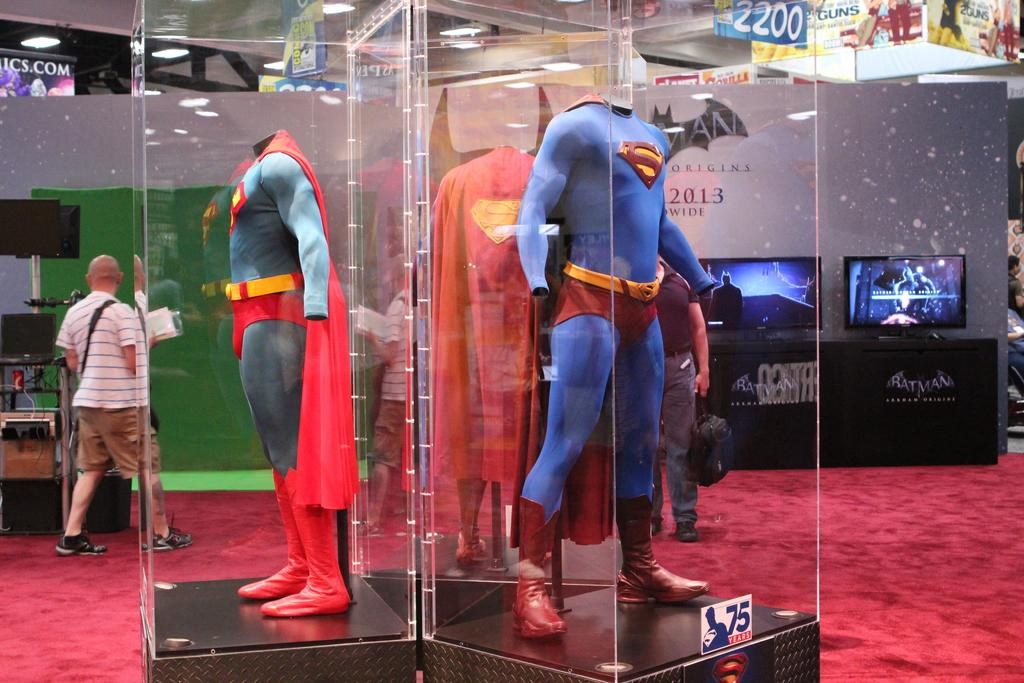<image>
Create a compact narrative representing the image presented. A computer screen sitting on a table with a black table cloth that says Batman on it 